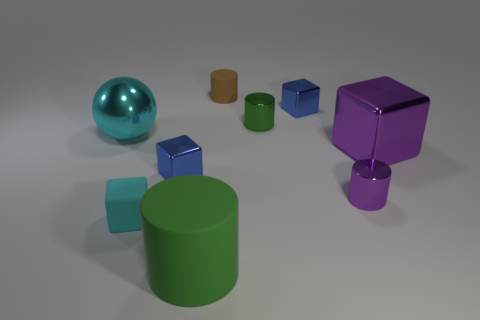Are there any shapes repeated in this image and if so, which ones? Yes, certain shapes are repeated. There are multiple cylinders and cubes visible, with the cylinders available in both large and small sizes, and the cubes appearing uniformly small. 